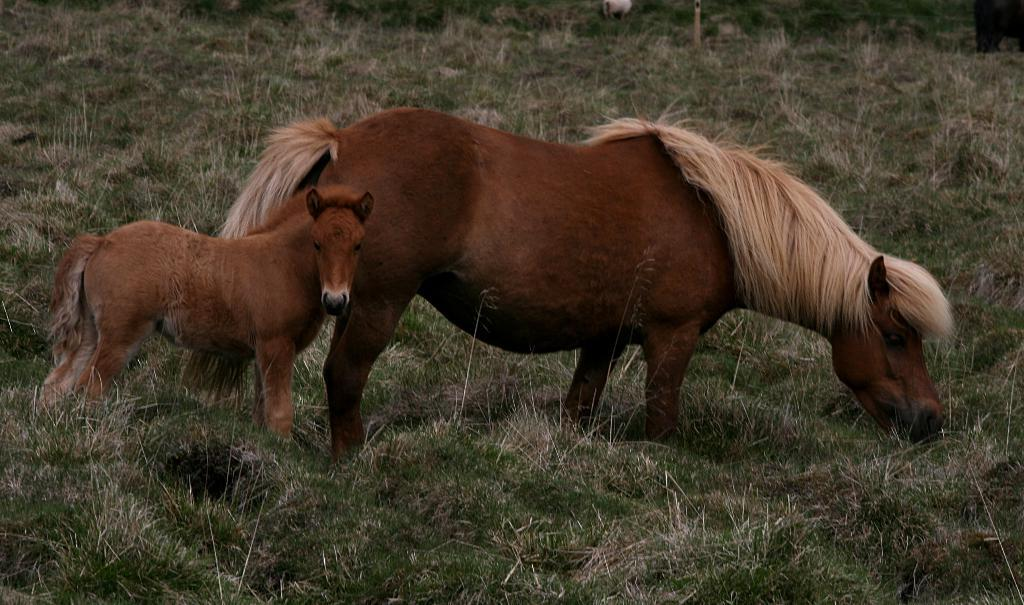How many animals are present in the image? There are two animals in the image. Where are the animals located? The animals are on the ground. What type of vegetation can be seen in the image? There is grass in the image. What type of prose is being recited by the animals in the image? There is no indication in the image that the animals are reciting any prose, as they are simply located on the ground. 